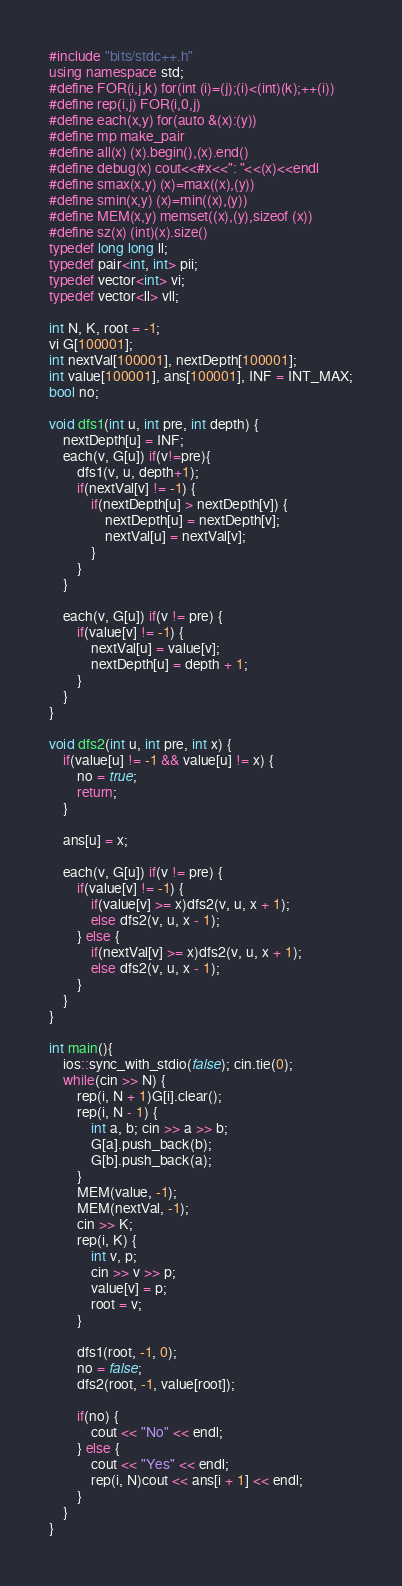Convert code to text. <code><loc_0><loc_0><loc_500><loc_500><_C++_>#include "bits/stdc++.h"
using namespace std;
#define FOR(i,j,k) for(int (i)=(j);(i)<(int)(k);++(i))
#define rep(i,j) FOR(i,0,j)
#define each(x,y) for(auto &(x):(y))
#define mp make_pair
#define all(x) (x).begin(),(x).end()
#define debug(x) cout<<#x<<": "<<(x)<<endl
#define smax(x,y) (x)=max((x),(y))
#define smin(x,y) (x)=min((x),(y))
#define MEM(x,y) memset((x),(y),sizeof (x))
#define sz(x) (int)(x).size()
typedef long long ll;
typedef pair<int, int> pii;
typedef vector<int> vi;
typedef vector<ll> vll;

int N, K, root = -1;
vi G[100001];
int nextVal[100001], nextDepth[100001];
int value[100001], ans[100001], INF = INT_MAX;
bool no;

void dfs1(int u, int pre, int depth) {
    nextDepth[u] = INF;
    each(v, G[u]) if(v!=pre){
        dfs1(v, u, depth+1);
        if(nextVal[v] != -1) {
            if(nextDepth[u] > nextDepth[v]) {
                nextDepth[u] = nextDepth[v];
                nextVal[u] = nextVal[v];
            }
        }
    }

    each(v, G[u]) if(v != pre) {
        if(value[v] != -1) {
            nextVal[u] = value[v];
            nextDepth[u] = depth + 1;
        }
    }
}

void dfs2(int u, int pre, int x) {
    if(value[u] != -1 && value[u] != x) {
        no = true;
        return;
    }

    ans[u] = x;
    
    each(v, G[u]) if(v != pre) {
        if(value[v] != -1) {
            if(value[v] >= x)dfs2(v, u, x + 1);
            else dfs2(v, u, x - 1);
        } else {
            if(nextVal[v] >= x)dfs2(v, u, x + 1);
            else dfs2(v, u, x - 1);
        }
    }
}

int main(){
    ios::sync_with_stdio(false); cin.tie(0);
    while(cin >> N) {
        rep(i, N + 1)G[i].clear();
        rep(i, N - 1) {
            int a, b; cin >> a >> b;
            G[a].push_back(b);
            G[b].push_back(a);
        }
        MEM(value, -1);
        MEM(nextVal, -1);
        cin >> K;
        rep(i, K) {
            int v, p;
            cin >> v >> p;
            value[v] = p;
            root = v;
        }

        dfs1(root, -1, 0);
        no = false;
        dfs2(root, -1, value[root]);

        if(no) {
            cout << "No" << endl;
        } else {
            cout << "Yes" << endl;
            rep(i, N)cout << ans[i + 1] << endl;
        }
    }
}</code> 